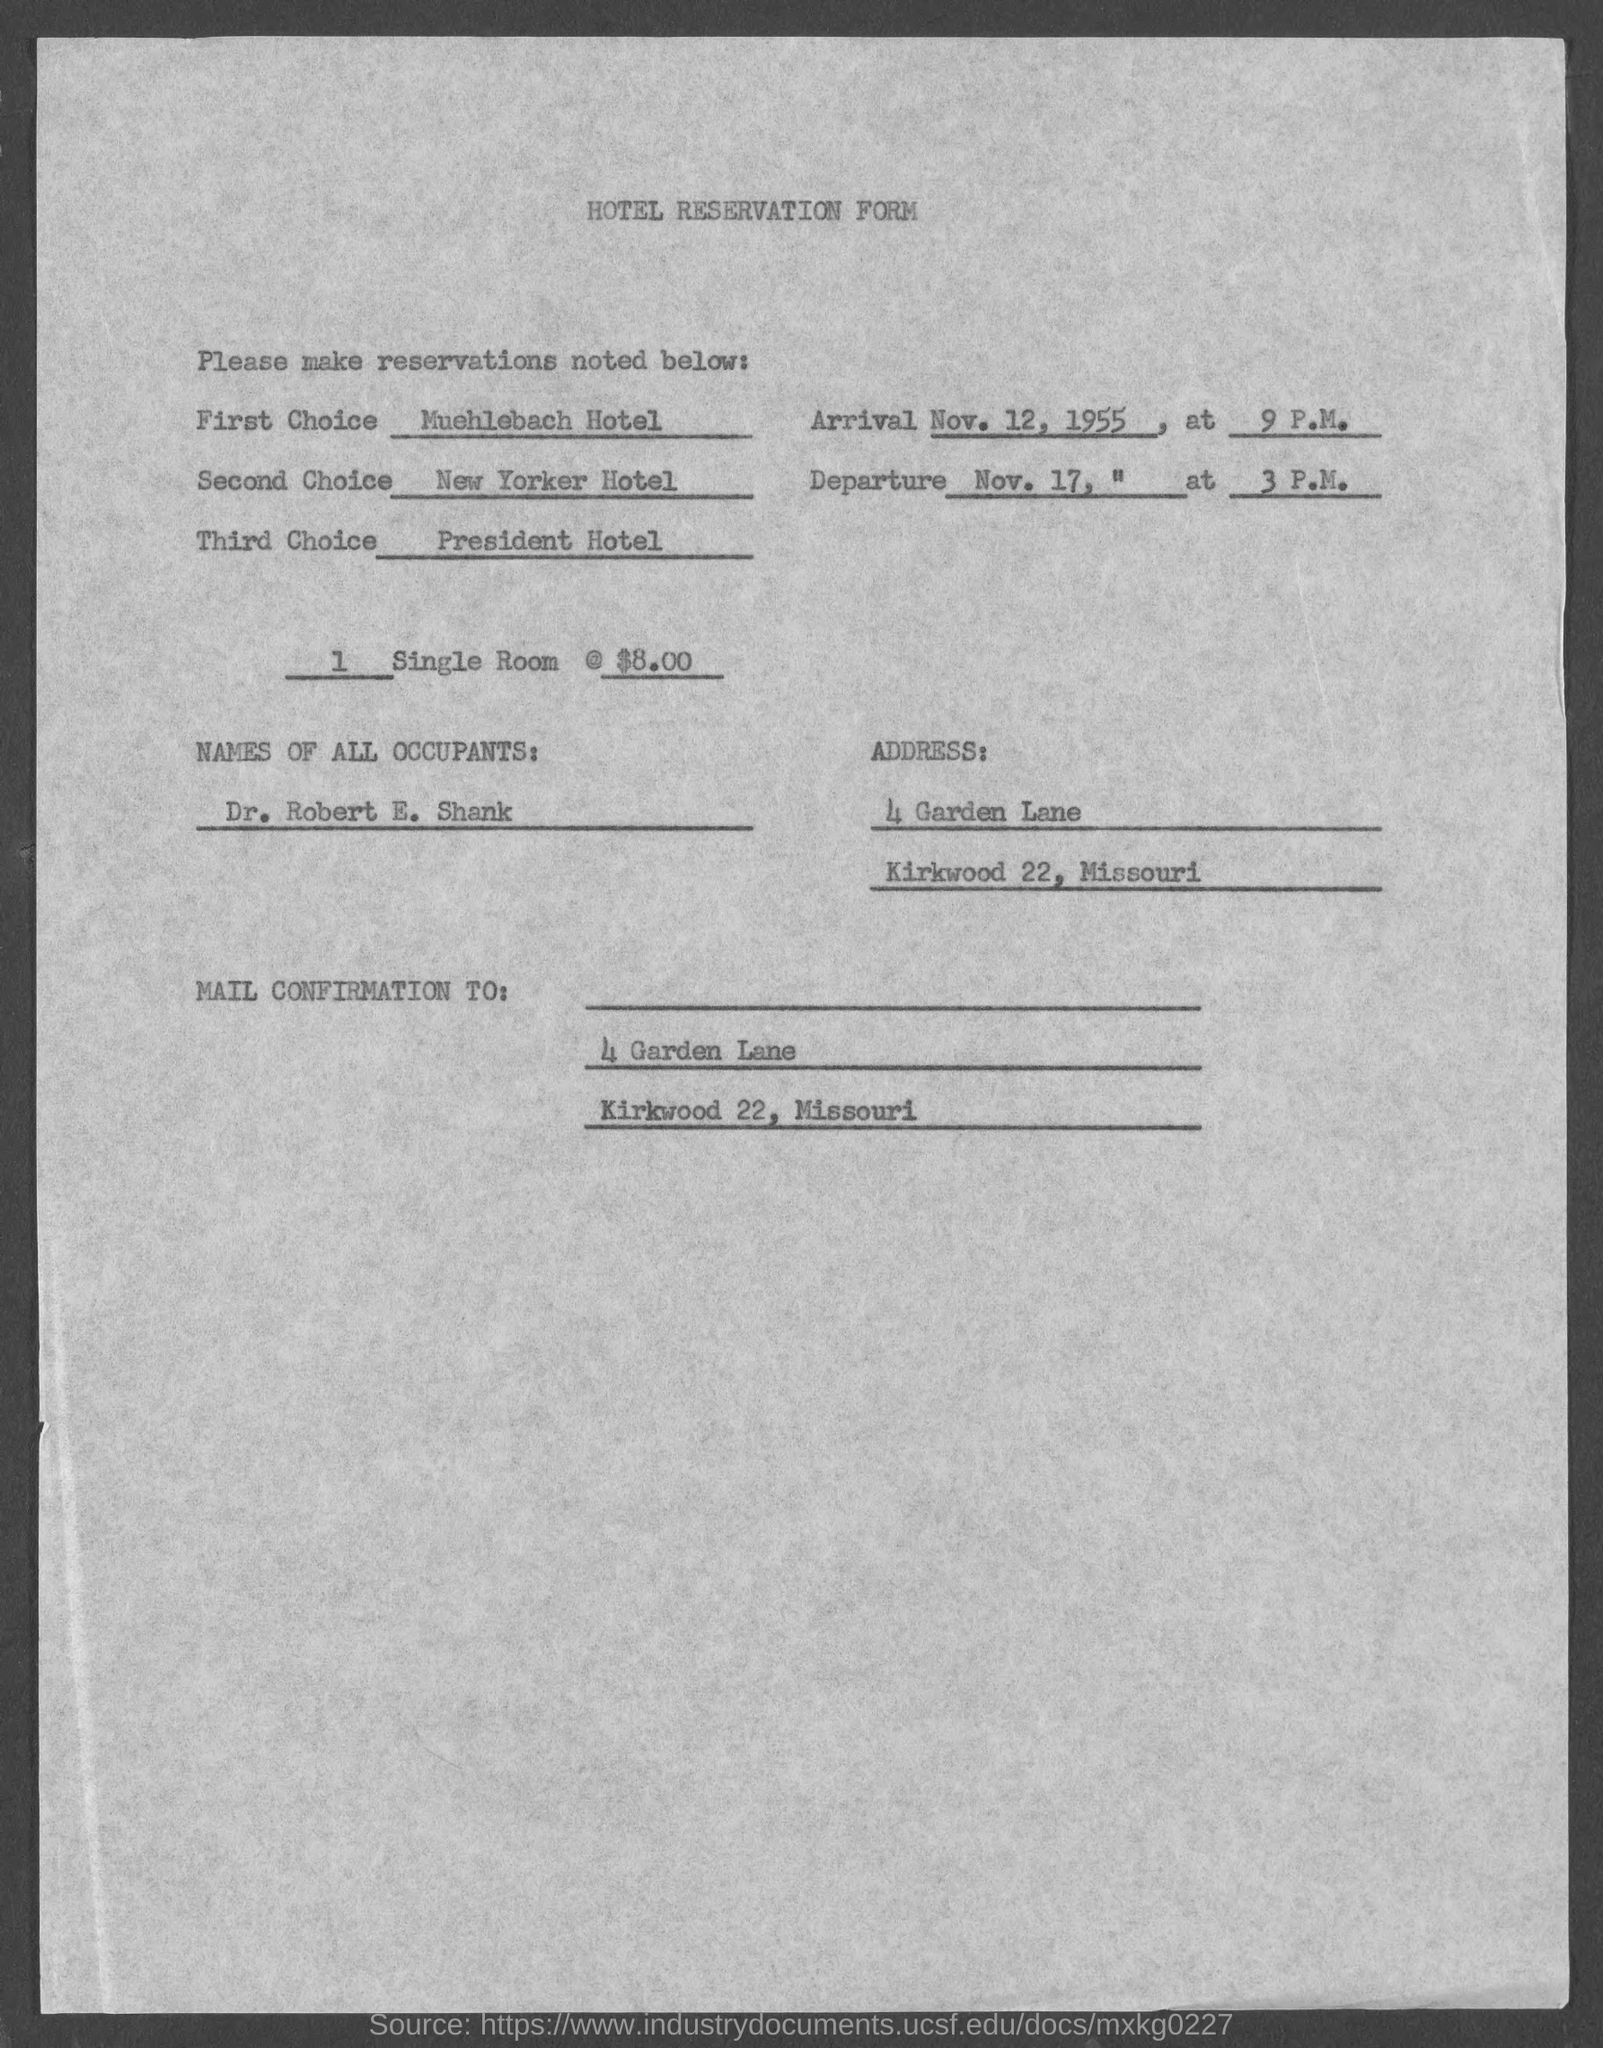Draw attention to some important aspects in this diagram. The name of the form is a hotel reservation form. The name of all occupants is Dr. Robert E. Shank. 